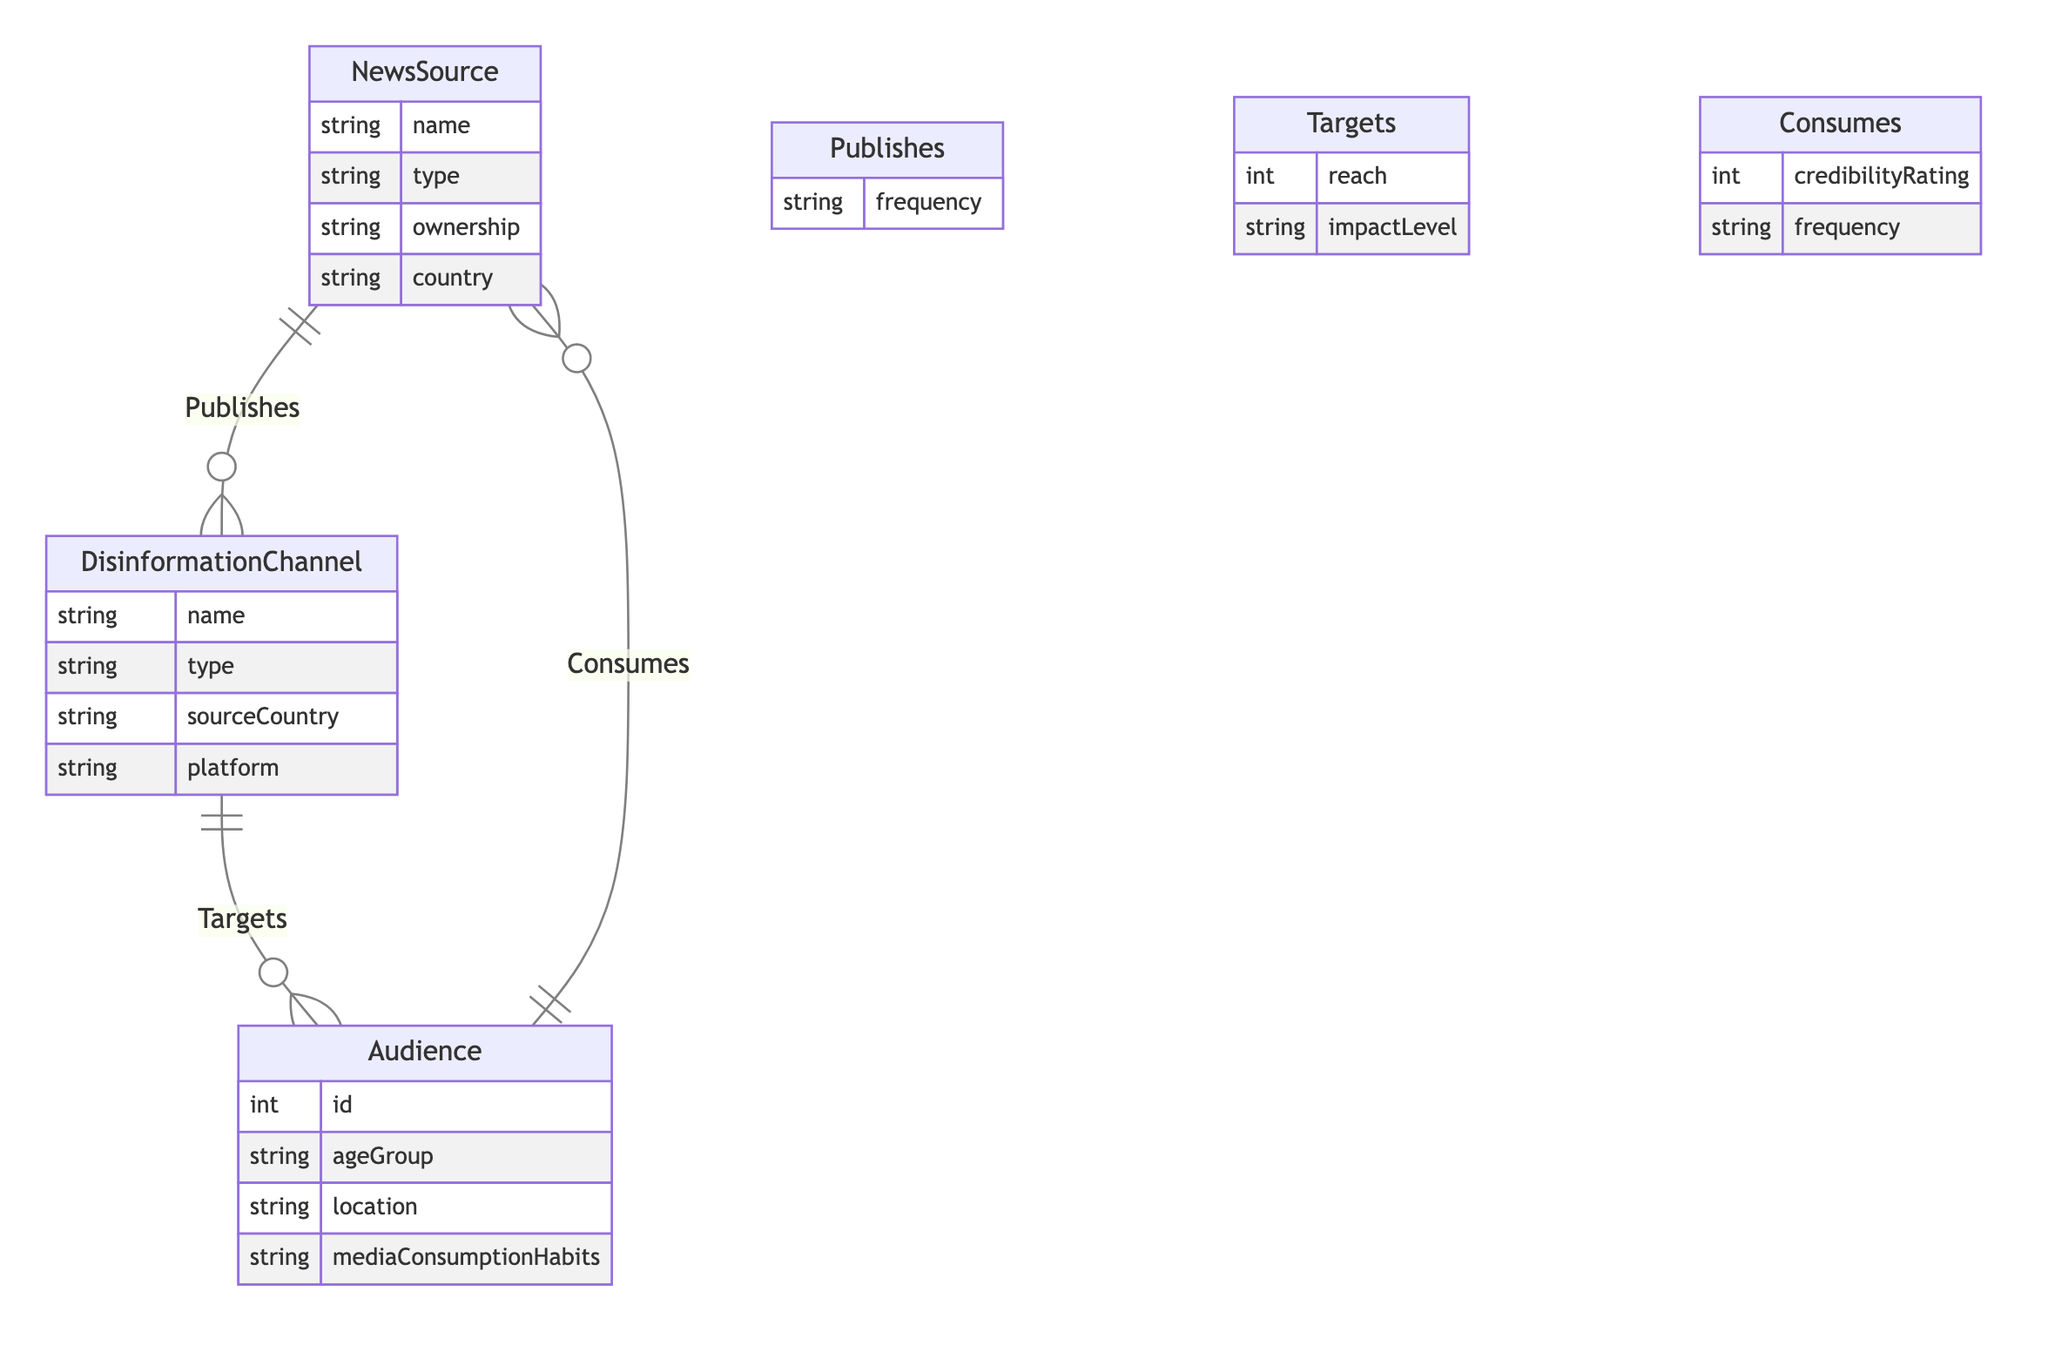What are the attributes of NewsSource? The attributes of the NewsSource entity include name, type, ownership, and country as indicated in the entity list of the diagram.
Answer: name, type, ownership, country How many attributes does DisinformationChannel have? DisinformationChannel has four attributes: name, type, sourceCountry, and platform. This count is directly observed from the entity description in the diagram.
Answer: 4 What relationship exists between NewsSource and DisinformationChannel? The relationship between NewsSource and DisinformationChannel is labeled as "Publishes," showing a directed connection where NewsSource can publish disinformation channels.
Answer: Publishes What does the Targets relationship indicate? The Targets relationship indicates that DisinformationChannel has a reach and impact level directed towards the Audience, which can be interpreted from the labels and attributes defined in the relationship section.
Answer: reach, impact level What attributes are associated with the Consumes relationship? The Consumes relationship connects Audience and NewsSource, and it includes credibilityRating and frequency as its associated attributes, per the relationship specifications in the diagram.
Answer: credibilityRating, frequency How many entities are represented in the diagram? There are three main entities in the diagram: NewsSource, DisinformationChannel, and Audience. This total is counted from the entities section of the diagram.
Answer: 3 Which entity is connected to Audience in the diagram? The Audience entity connects to both DisinformationChannel and NewsSource through the relationships Targets and Consumes respectively, indicating a two-way interaction.
Answer: DisinformationChannel, NewsSource What is the frequency in the Publishes relationship? The frequency attribute in the Publishes relationship indicates how often a NewsSource publishes a DisinformationChannel, serving as a quantitative measure of that relationship.
Answer: frequency What type of diagram is represented here? The diagram is an Entity Relationship Diagram (ER Diagram), which is evident from the structure focusing on entities, attributes, and relationships among them.
Answer: Entity Relationship Diagram 